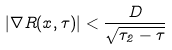<formula> <loc_0><loc_0><loc_500><loc_500>| \nabla R ( x , \tau ) | < \frac { D } { \sqrt { \tau _ { 2 } - \tau } }</formula> 